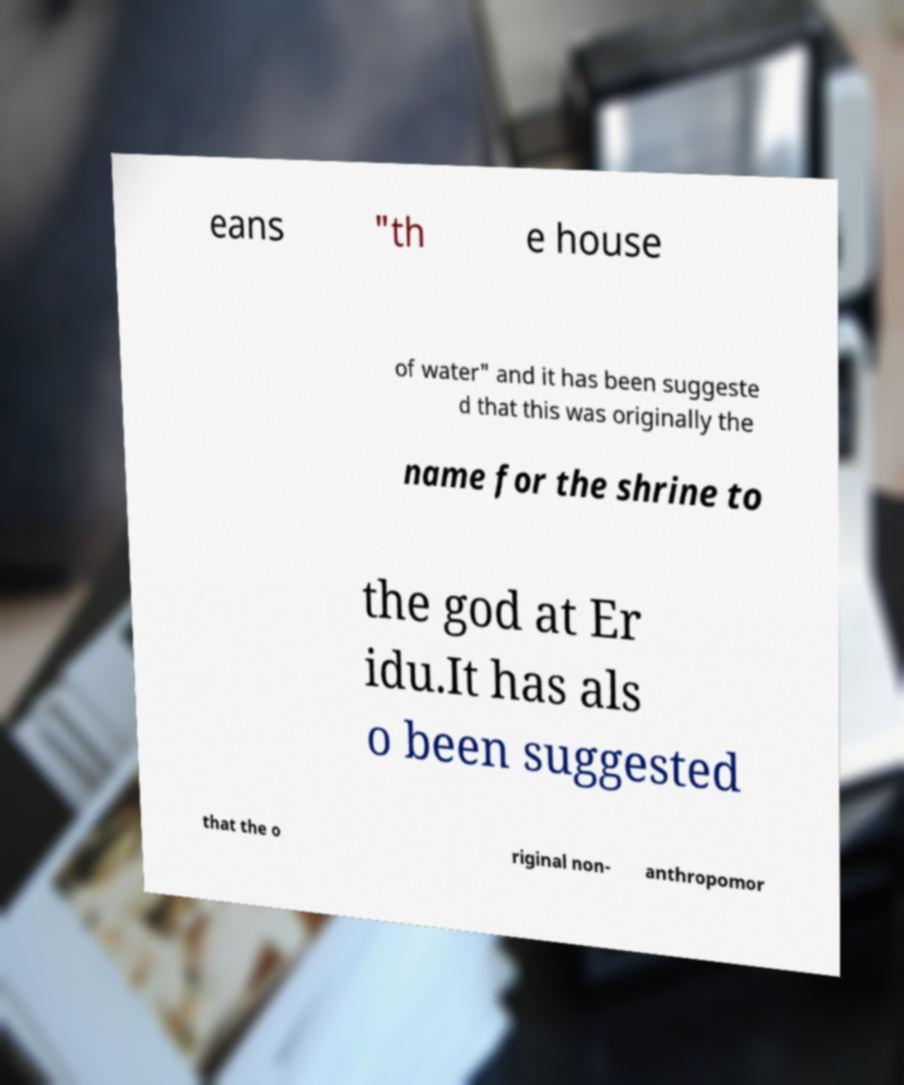Can you read and provide the text displayed in the image?This photo seems to have some interesting text. Can you extract and type it out for me? eans "th e house of water" and it has been suggeste d that this was originally the name for the shrine to the god at Er idu.It has als o been suggested that the o riginal non- anthropomor 